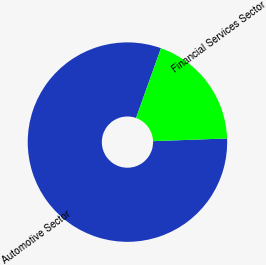Convert chart. <chart><loc_0><loc_0><loc_500><loc_500><pie_chart><fcel>Automotive Sector<fcel>Financial Services Sector<nl><fcel>81.04%<fcel>18.96%<nl></chart> 